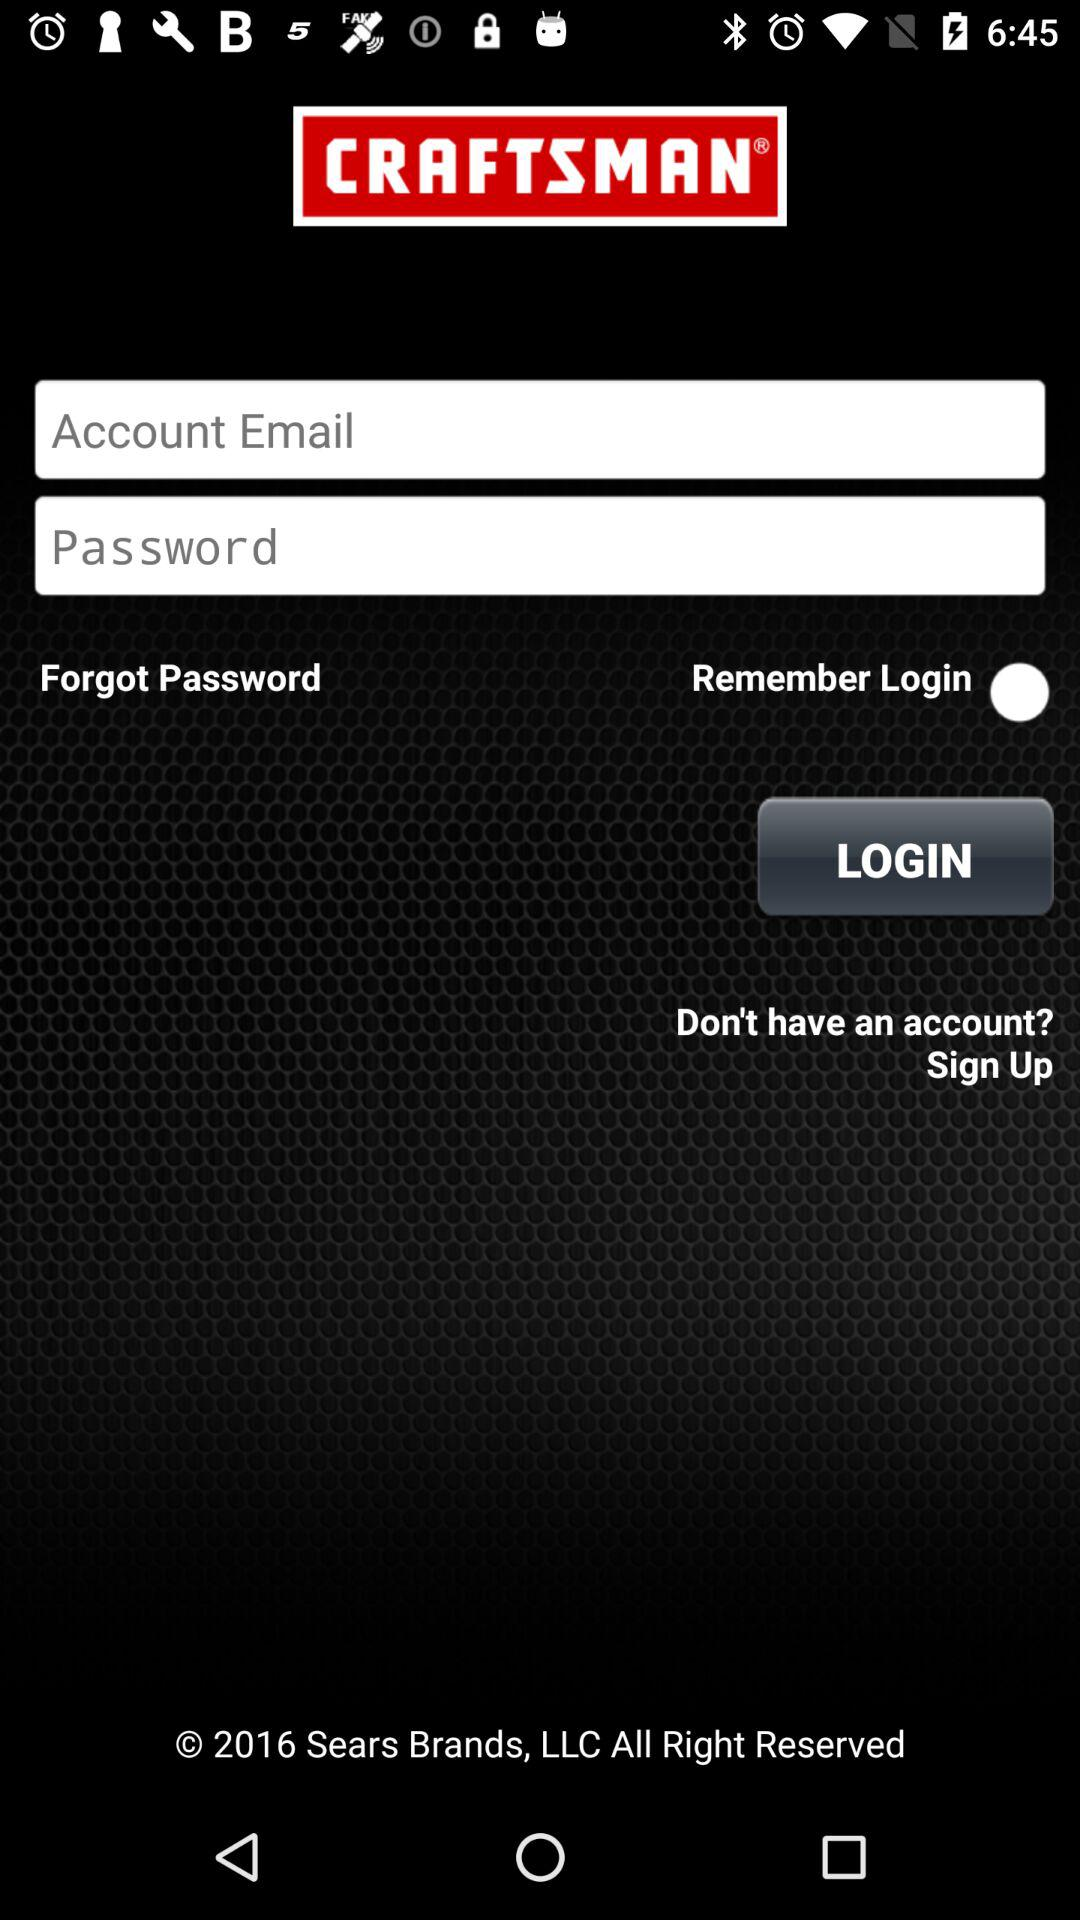How many input fields are there for the login screen?
Answer the question using a single word or phrase. 2 